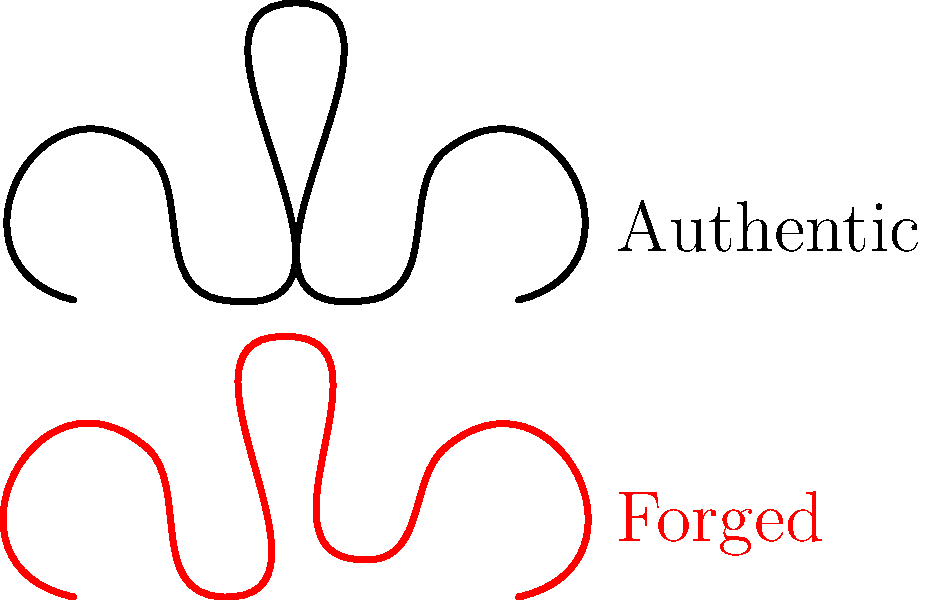In the image above, two signatures are shown: an authentic signature and a forged one. Identify the key difference between these signatures that would help determine the forgery. To identify the key difference between the authentic and forged signatures, follow these steps:

1. Examine the overall shape and flow of both signatures.
2. Focus on the middle section of each signature, where the most prominent peak occurs.
3. In the authentic signature, this peak reaches higher and is more pronounced.
4. The forged signature's peak is slightly lower and less sharp.
5. Notice that the forged signature also has a slight deviation in the trough following the peak, being slightly higher than the authentic one.
6. The difference in the height and sharpness of the central peak is the most significant and easily identifiable difference between the two signatures.

This subtle difference in the central peak is a common indicator of forgery, as forgers often struggle to replicate the exact pressure and speed of the original signer, especially in the most distinctive parts of the signature.
Answer: Height and sharpness of the central peak 